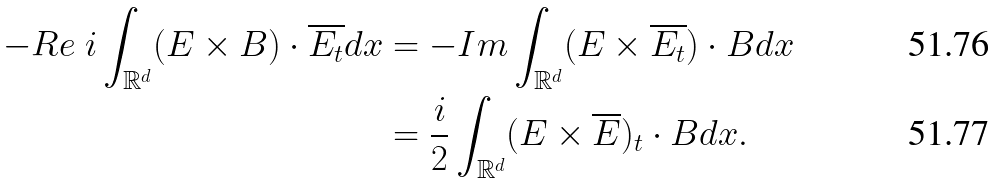Convert formula to latex. <formula><loc_0><loc_0><loc_500><loc_500>- R e \ i \int _ { \mathbb { R } ^ { d } } ( E \times B ) \cdot \overline { E _ { t } } d x & = - I m \int _ { \mathbb { R } ^ { d } } ( E \times \overline { E _ { t } } ) \cdot B d x \\ & = \frac { i } { 2 } \int _ { \mathbb { R } ^ { d } } ( E \times \overline { E } ) _ { t } \cdot B d x .</formula> 